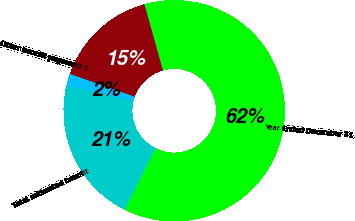Convert chart. <chart><loc_0><loc_0><loc_500><loc_500><pie_chart><fcel>Year Ended December 31<fcel>Pension benefit payments<fcel>Other benefit payments 1<fcel>Total estimated benefit<nl><fcel>61.73%<fcel>15.26%<fcel>1.74%<fcel>21.26%<nl></chart> 